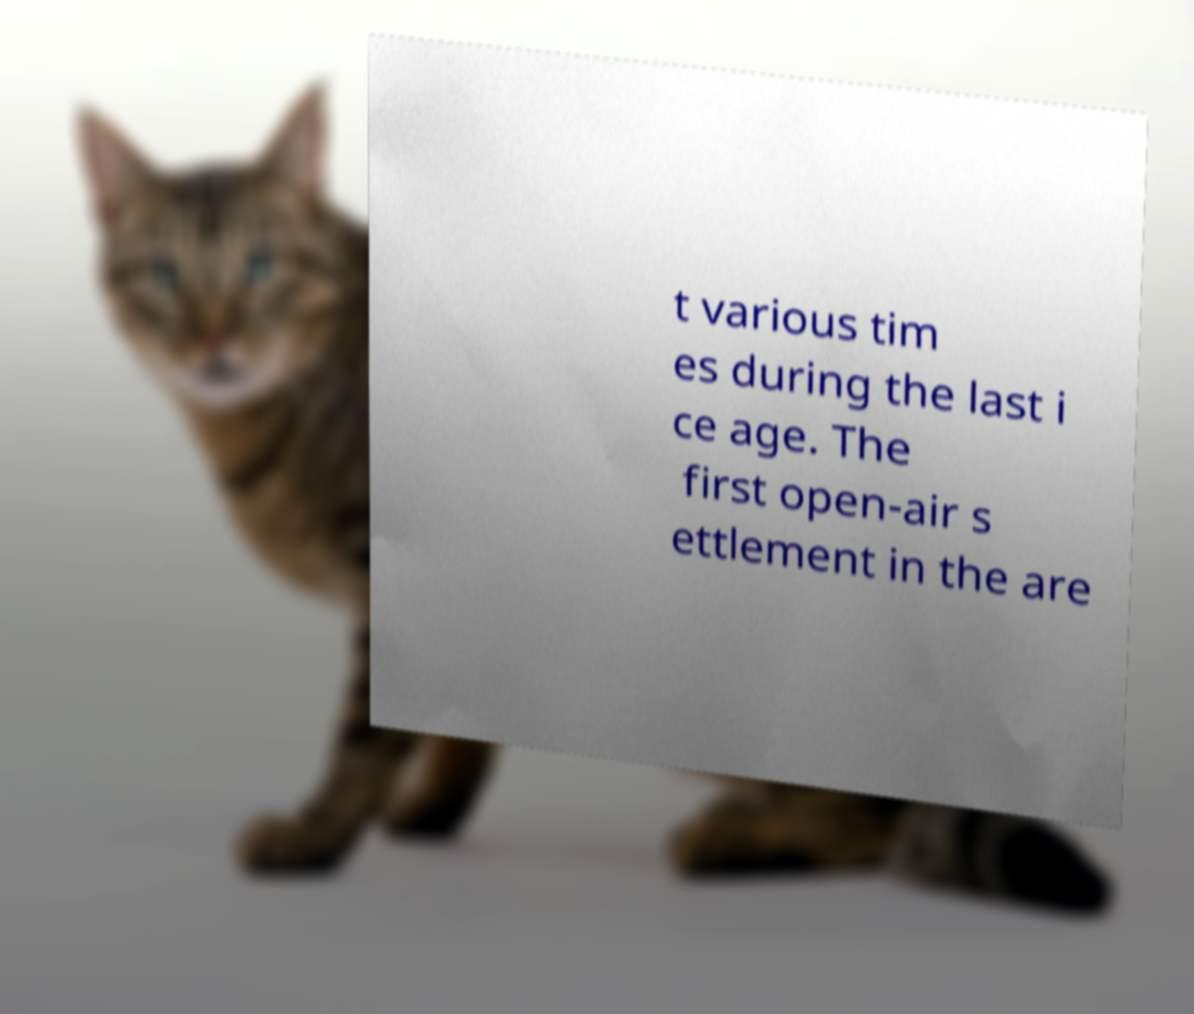Please read and relay the text visible in this image. What does it say? t various tim es during the last i ce age. The first open-air s ettlement in the are 